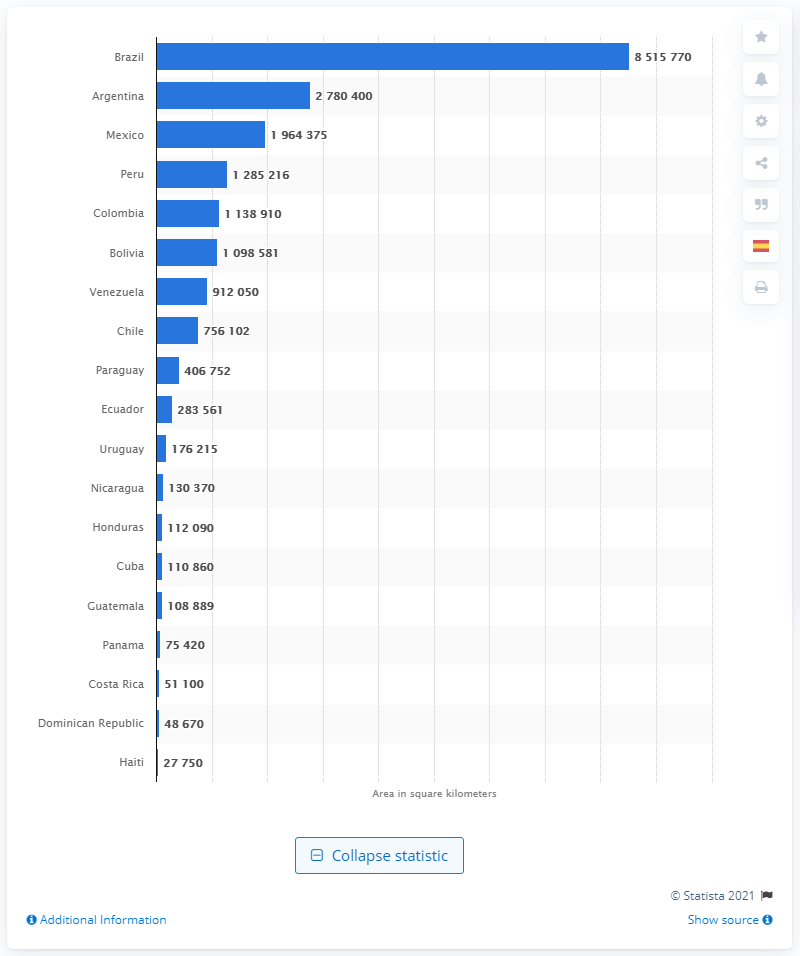Outline some significant characteristics in this image. Brazil is the largest country in Latin America. Cuba is the largest country in the Caribbean. According to the information provided, Brazil's total land area is approximately 8,515,770 square kilometers. The largest country in Latin America is Argentina. 